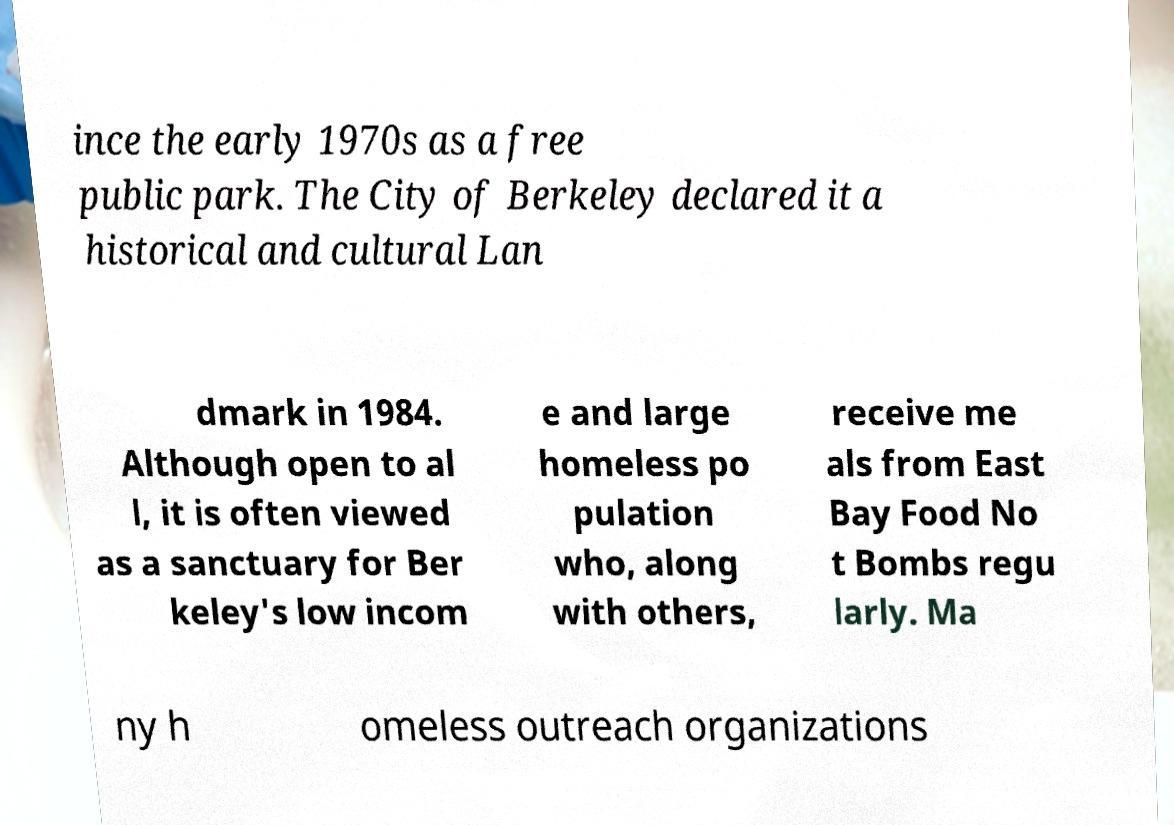For documentation purposes, I need the text within this image transcribed. Could you provide that? ince the early 1970s as a free public park. The City of Berkeley declared it a historical and cultural Lan dmark in 1984. Although open to al l, it is often viewed as a sanctuary for Ber keley's low incom e and large homeless po pulation who, along with others, receive me als from East Bay Food No t Bombs regu larly. Ma ny h omeless outreach organizations 